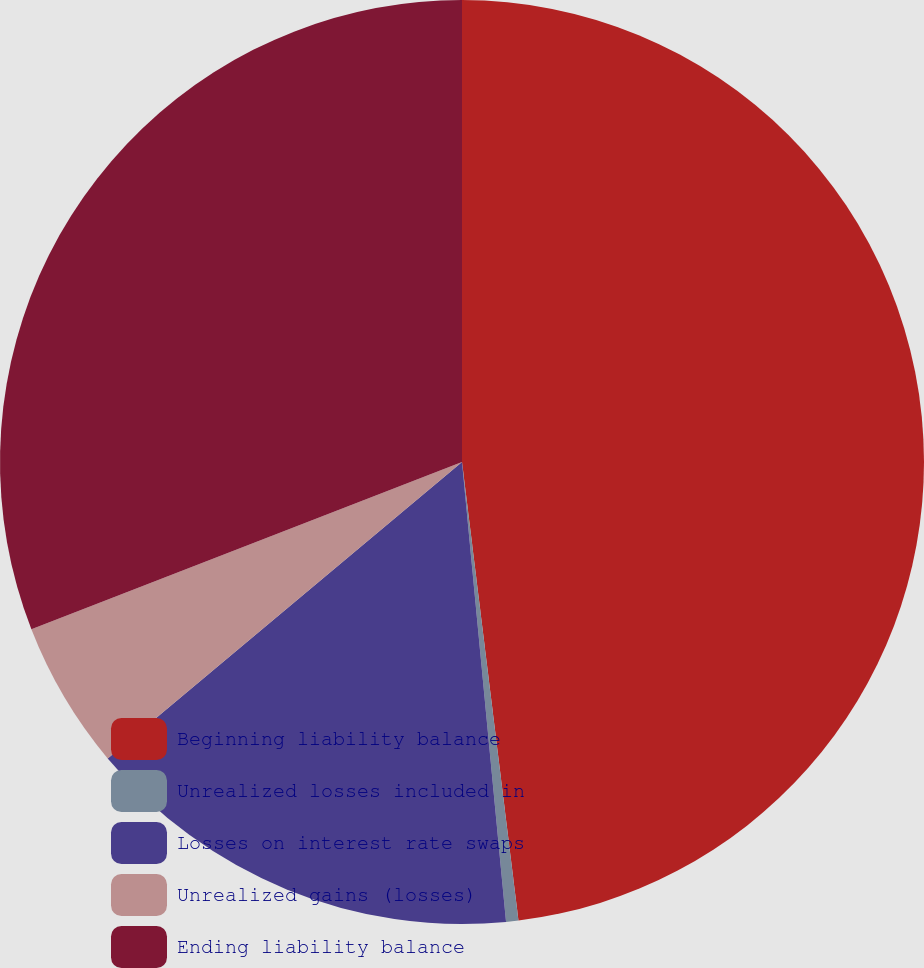<chart> <loc_0><loc_0><loc_500><loc_500><pie_chart><fcel>Beginning liability balance<fcel>Unrealized losses included in<fcel>Losses on interest rate swaps<fcel>Unrealized gains (losses)<fcel>Ending liability balance<nl><fcel>48.05%<fcel>0.43%<fcel>15.43%<fcel>5.19%<fcel>30.9%<nl></chart> 